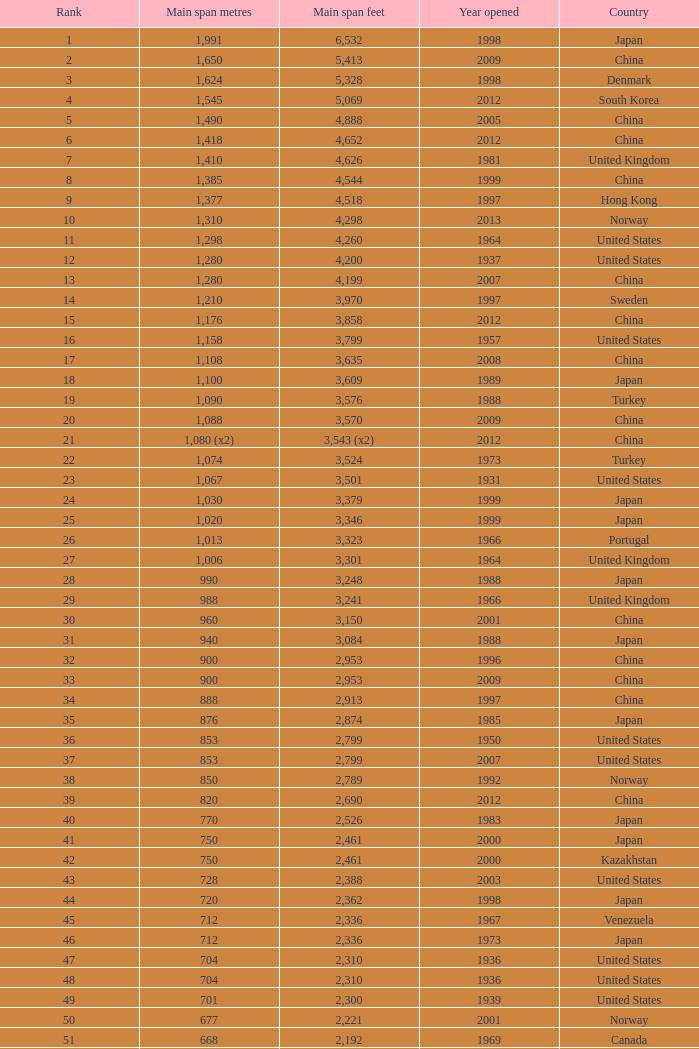What is the oldest year with a main span feet of 1,640 in South Korea? 2002.0. 